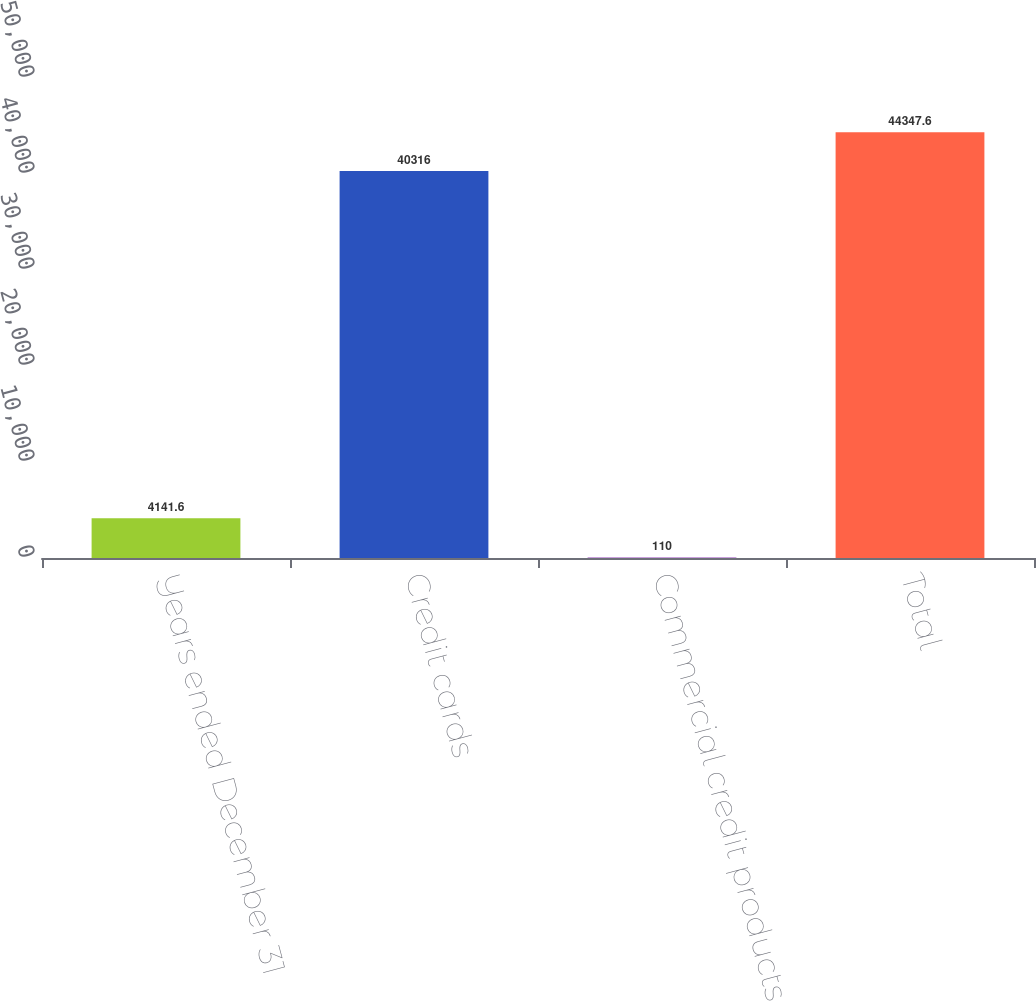Convert chart to OTSL. <chart><loc_0><loc_0><loc_500><loc_500><bar_chart><fcel>Years ended December 31<fcel>Credit cards<fcel>Commercial credit products<fcel>Total<nl><fcel>4141.6<fcel>40316<fcel>110<fcel>44347.6<nl></chart> 